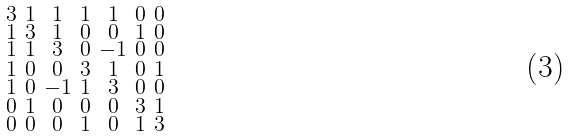Convert formula to latex. <formula><loc_0><loc_0><loc_500><loc_500>\begin{smallmatrix} 3 & 1 & 1 & 1 & 1 & 0 & 0 \\ 1 & 3 & 1 & 0 & 0 & 1 & 0 \\ 1 & 1 & 3 & 0 & - 1 & 0 & 0 \\ 1 & 0 & 0 & 3 & 1 & 0 & 1 \\ 1 & 0 & - 1 & 1 & 3 & 0 & 0 \\ 0 & 1 & 0 & 0 & 0 & 3 & 1 \\ 0 & 0 & 0 & 1 & 0 & 1 & 3 \end{smallmatrix}</formula> 